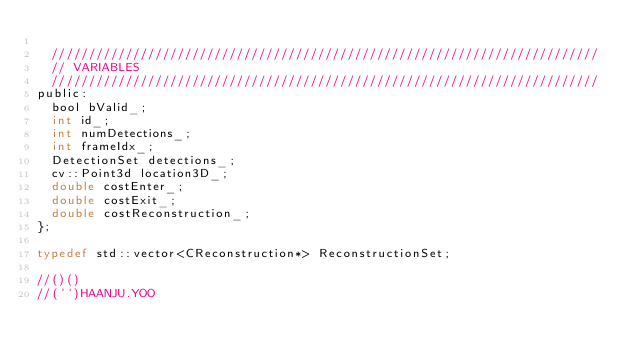Convert code to text. <code><loc_0><loc_0><loc_500><loc_500><_C_>
	//////////////////////////////////////////////////////////////////////////
	// VARIABLES
	//////////////////////////////////////////////////////////////////////////
public:
	bool bValid_;
	int id_;
	int numDetections_;
	int frameIdx_;
	DetectionSet detections_;
	cv::Point3d location3D_;
	double costEnter_;
	double costExit_;
	double costReconstruction_;	
};

typedef std::vector<CReconstruction*> ReconstructionSet;

//()()
//('')HAANJU.YOO

</code> 